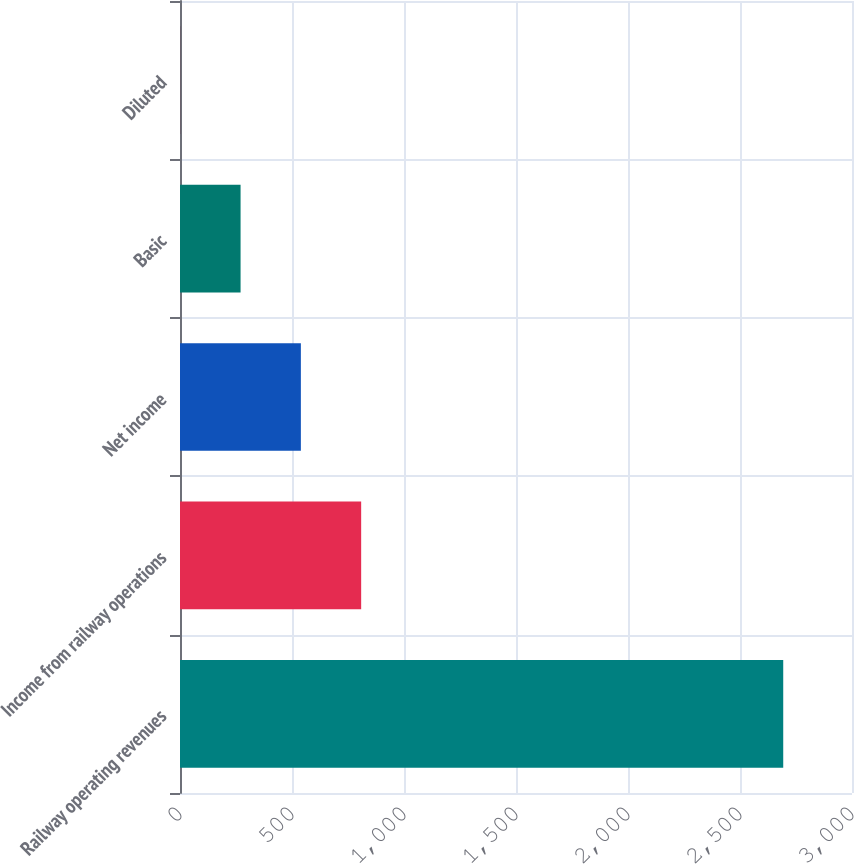Convert chart. <chart><loc_0><loc_0><loc_500><loc_500><bar_chart><fcel>Railway operating revenues<fcel>Income from railway operations<fcel>Net income<fcel>Basic<fcel>Diluted<nl><fcel>2693<fcel>808.78<fcel>539.6<fcel>270.42<fcel>1.24<nl></chart> 